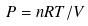Convert formula to latex. <formula><loc_0><loc_0><loc_500><loc_500>P = n R T / V</formula> 